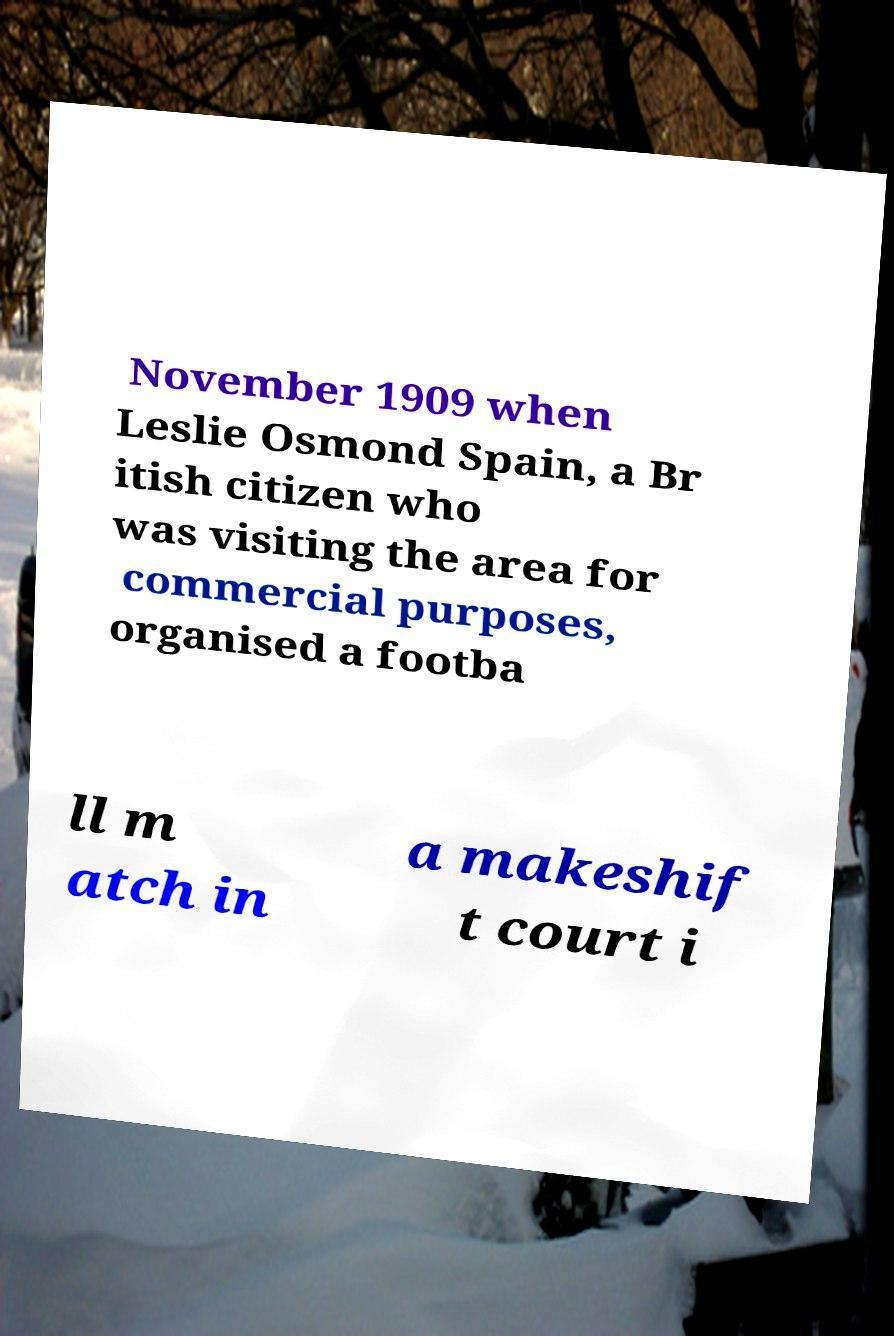Please read and relay the text visible in this image. What does it say? November 1909 when Leslie Osmond Spain, a Br itish citizen who was visiting the area for commercial purposes, organised a footba ll m atch in a makeshif t court i 